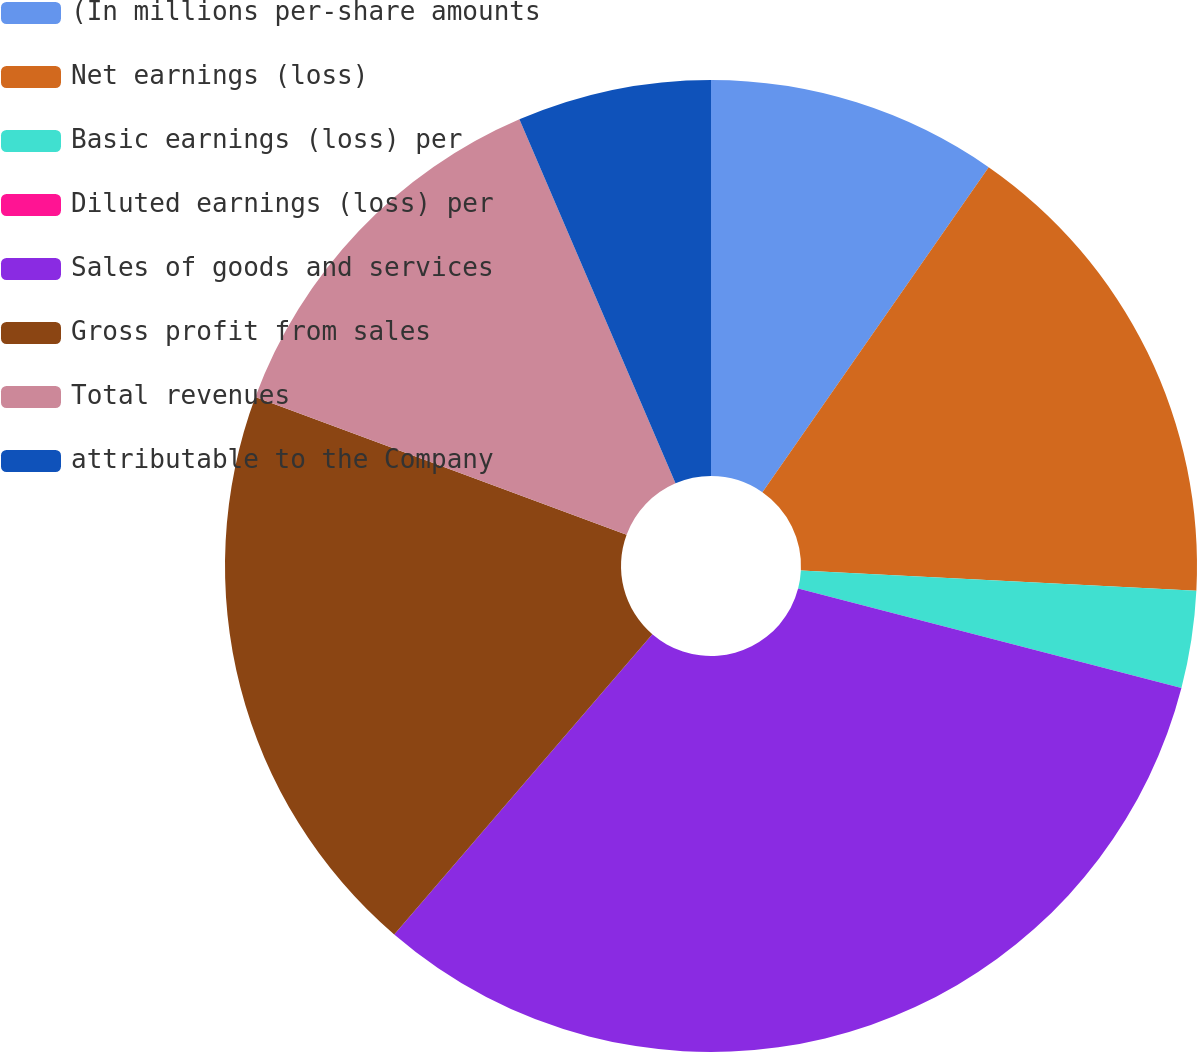Convert chart. <chart><loc_0><loc_0><loc_500><loc_500><pie_chart><fcel>(In millions per-share amounts<fcel>Net earnings (loss)<fcel>Basic earnings (loss) per<fcel>Diluted earnings (loss) per<fcel>Sales of goods and services<fcel>Gross profit from sales<fcel>Total revenues<fcel>attributable to the Company<nl><fcel>9.68%<fcel>16.13%<fcel>3.23%<fcel>0.0%<fcel>32.26%<fcel>19.35%<fcel>12.9%<fcel>6.45%<nl></chart> 